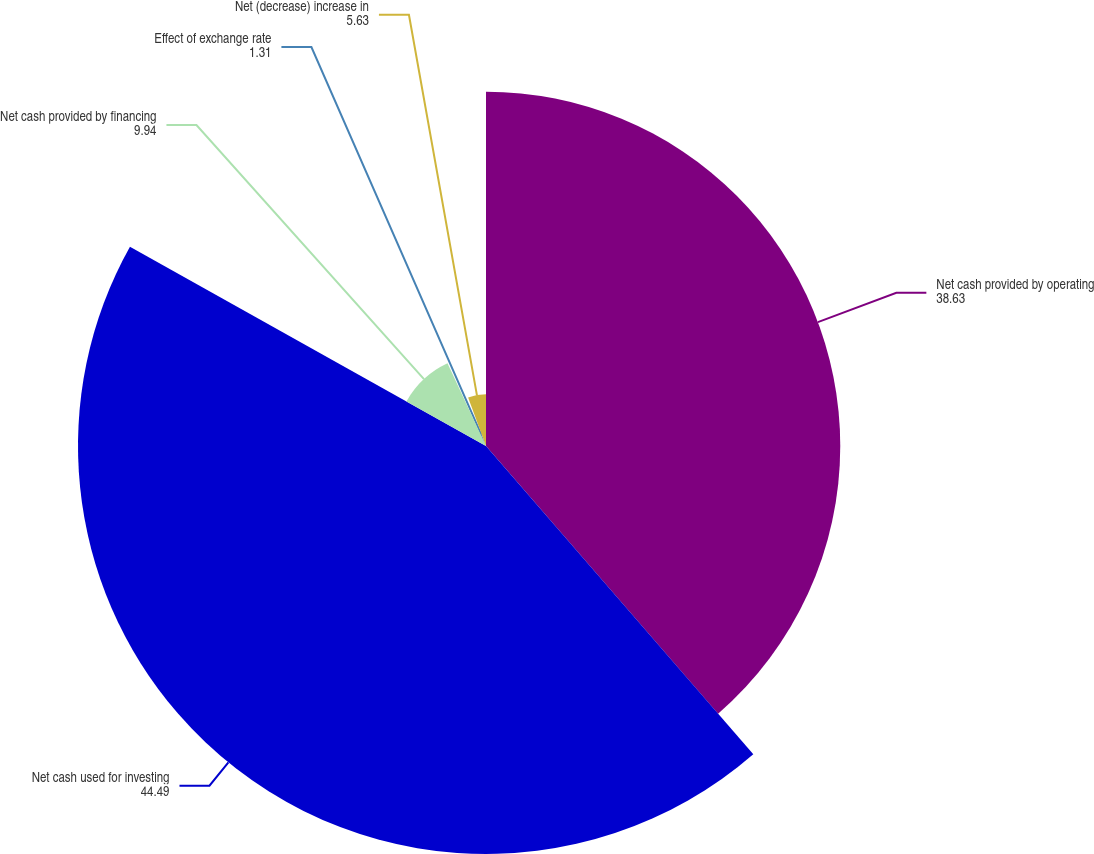Convert chart. <chart><loc_0><loc_0><loc_500><loc_500><pie_chart><fcel>Net cash provided by operating<fcel>Net cash used for investing<fcel>Net cash provided by financing<fcel>Effect of exchange rate<fcel>Net (decrease) increase in<nl><fcel>38.63%<fcel>44.49%<fcel>9.94%<fcel>1.31%<fcel>5.63%<nl></chart> 